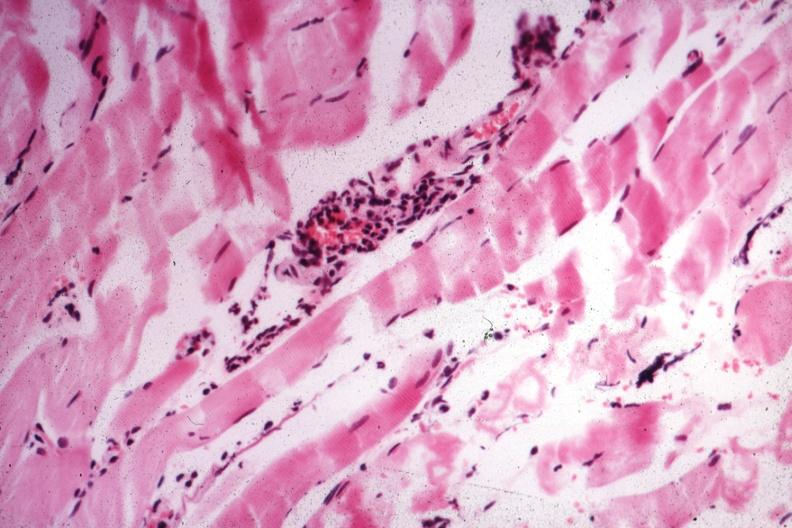s muscle present?
Answer the question using a single word or phrase. Yes 